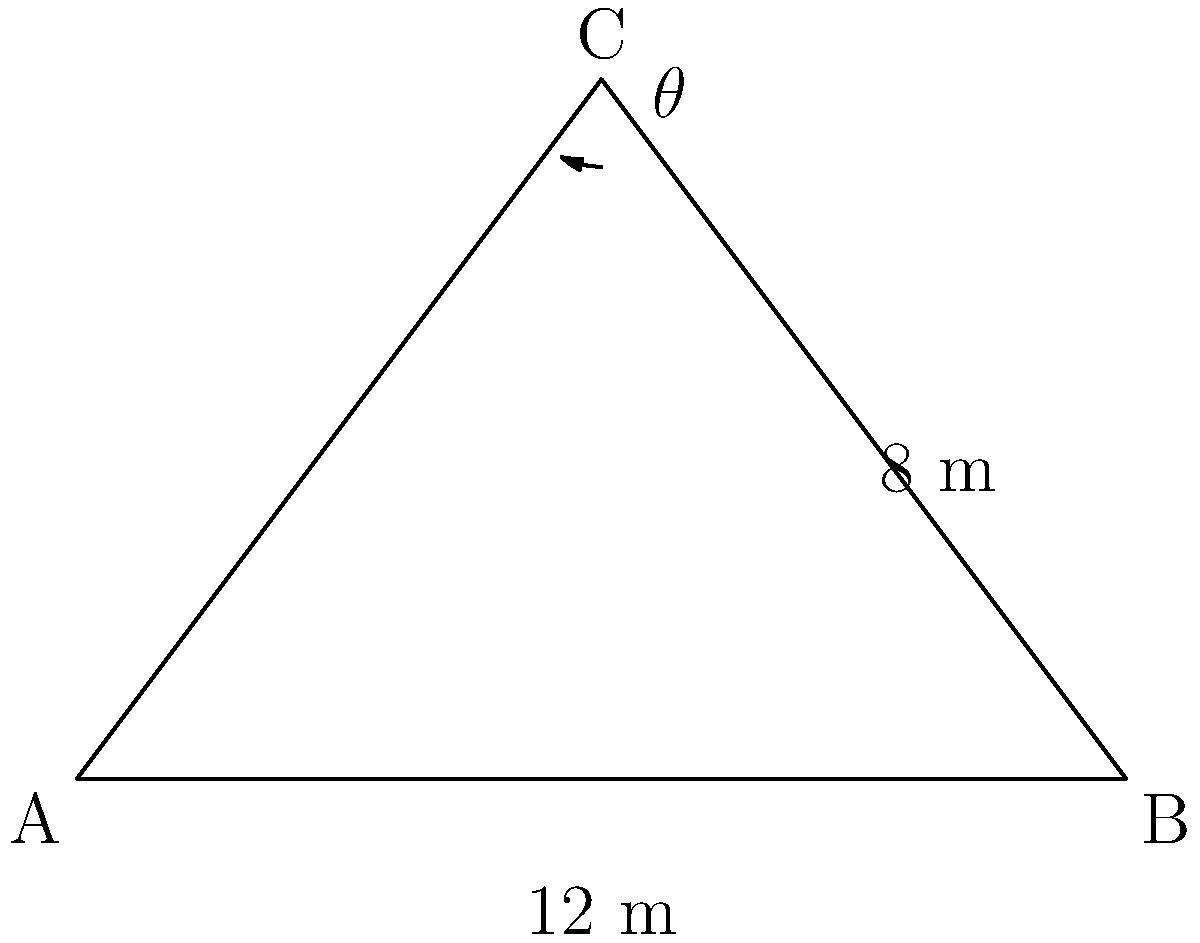In an ancient Portuguese synagogue, the roof forms an isosceles triangle. The base of the roof is 12 meters wide, and the height from the base to the peak is 8 meters. Calculate the angle of inclination (θ) of the roof with respect to the horizontal base. To solve this problem, we'll use trigonometry:

1. The roof forms an isosceles triangle, so we can split it into two right triangles.
2. In one right triangle:
   - The base is half of the total width: $12 \div 2 = 6$ meters
   - The height remains 8 meters
3. We need to find the angle between the base and the hypotenuse (roof)
4. This can be done using the tangent function:

   $$\tan(\theta) = \frac{\text{opposite}}{\text{adjacent}} = \frac{8}{6}$$

5. To find θ, we need to use the inverse tangent (arctan):

   $$\theta = \arctan(\frac{8}{6})$$

6. Calculate:
   $$\theta = \arctan(1.3333...) \approx 53.13^\circ$$

Therefore, the angle of inclination of the roof is approximately 53.13°.
Answer: $53.13^\circ$ 